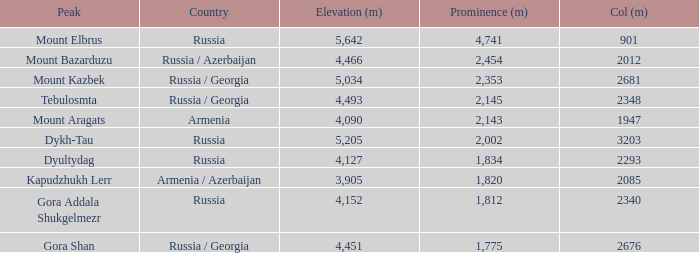What is the altitude (m) of the peak with a prominence (m) exceeding 2,143 and a col (m) of 2012? 4466.0. 